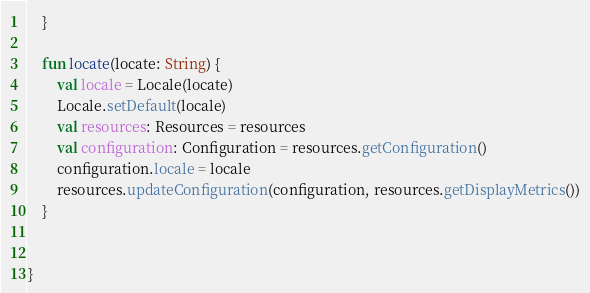Convert code to text. <code><loc_0><loc_0><loc_500><loc_500><_Kotlin_>    }

    fun locate(locate: String) {
        val locale = Locale(locate)
        Locale.setDefault(locale)
        val resources: Resources = resources
        val configuration: Configuration = resources.getConfiguration()
        configuration.locale = locale
        resources.updateConfiguration(configuration, resources.getDisplayMetrics())
    }


}
</code> 